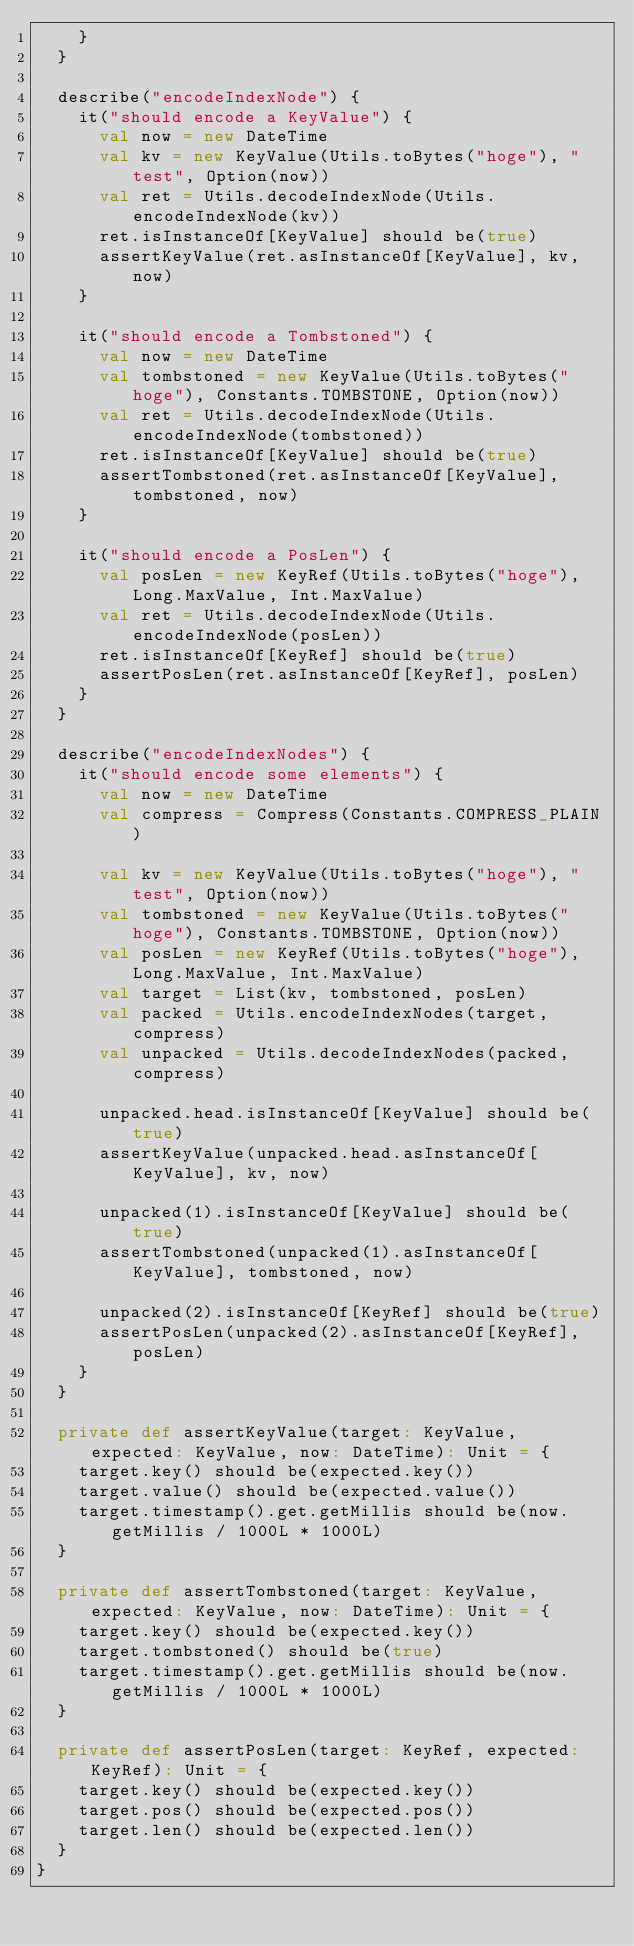<code> <loc_0><loc_0><loc_500><loc_500><_Scala_>    }
  }

  describe("encodeIndexNode") {
    it("should encode a KeyValue") {
      val now = new DateTime
      val kv = new KeyValue(Utils.toBytes("hoge"), "test", Option(now))
      val ret = Utils.decodeIndexNode(Utils.encodeIndexNode(kv))
      ret.isInstanceOf[KeyValue] should be(true)
      assertKeyValue(ret.asInstanceOf[KeyValue], kv, now)
    }

    it("should encode a Tombstoned") {
      val now = new DateTime
      val tombstoned = new KeyValue(Utils.toBytes("hoge"), Constants.TOMBSTONE, Option(now))
      val ret = Utils.decodeIndexNode(Utils.encodeIndexNode(tombstoned))
      ret.isInstanceOf[KeyValue] should be(true)
      assertTombstoned(ret.asInstanceOf[KeyValue], tombstoned, now)
    }

    it("should encode a PosLen") {
      val posLen = new KeyRef(Utils.toBytes("hoge"), Long.MaxValue, Int.MaxValue)
      val ret = Utils.decodeIndexNode(Utils.encodeIndexNode(posLen))
      ret.isInstanceOf[KeyRef] should be(true)
      assertPosLen(ret.asInstanceOf[KeyRef], posLen)
    }
  }

  describe("encodeIndexNodes") {
    it("should encode some elements") {
      val now = new DateTime
      val compress = Compress(Constants.COMPRESS_PLAIN)

      val kv = new KeyValue(Utils.toBytes("hoge"), "test", Option(now))
      val tombstoned = new KeyValue(Utils.toBytes("hoge"), Constants.TOMBSTONE, Option(now))
      val posLen = new KeyRef(Utils.toBytes("hoge"), Long.MaxValue, Int.MaxValue)
      val target = List(kv, tombstoned, posLen)
      val packed = Utils.encodeIndexNodes(target, compress)
      val unpacked = Utils.decodeIndexNodes(packed, compress)

      unpacked.head.isInstanceOf[KeyValue] should be(true)
      assertKeyValue(unpacked.head.asInstanceOf[KeyValue], kv, now)

      unpacked(1).isInstanceOf[KeyValue] should be(true)
      assertTombstoned(unpacked(1).asInstanceOf[KeyValue], tombstoned, now)

      unpacked(2).isInstanceOf[KeyRef] should be(true)
      assertPosLen(unpacked(2).asInstanceOf[KeyRef], posLen)
    }
  }

  private def assertKeyValue(target: KeyValue, expected: KeyValue, now: DateTime): Unit = {
    target.key() should be(expected.key())
    target.value() should be(expected.value())
    target.timestamp().get.getMillis should be(now.getMillis / 1000L * 1000L)
  }

  private def assertTombstoned(target: KeyValue, expected: KeyValue, now: DateTime): Unit = {
    target.key() should be(expected.key())
    target.tombstoned() should be(true)
    target.timestamp().get.getMillis should be(now.getMillis / 1000L * 1000L)
  }

  private def assertPosLen(target: KeyRef, expected: KeyRef): Unit = {
    target.key() should be(expected.key())
    target.pos() should be(expected.pos())
    target.len() should be(expected.len())
  }
}
</code> 